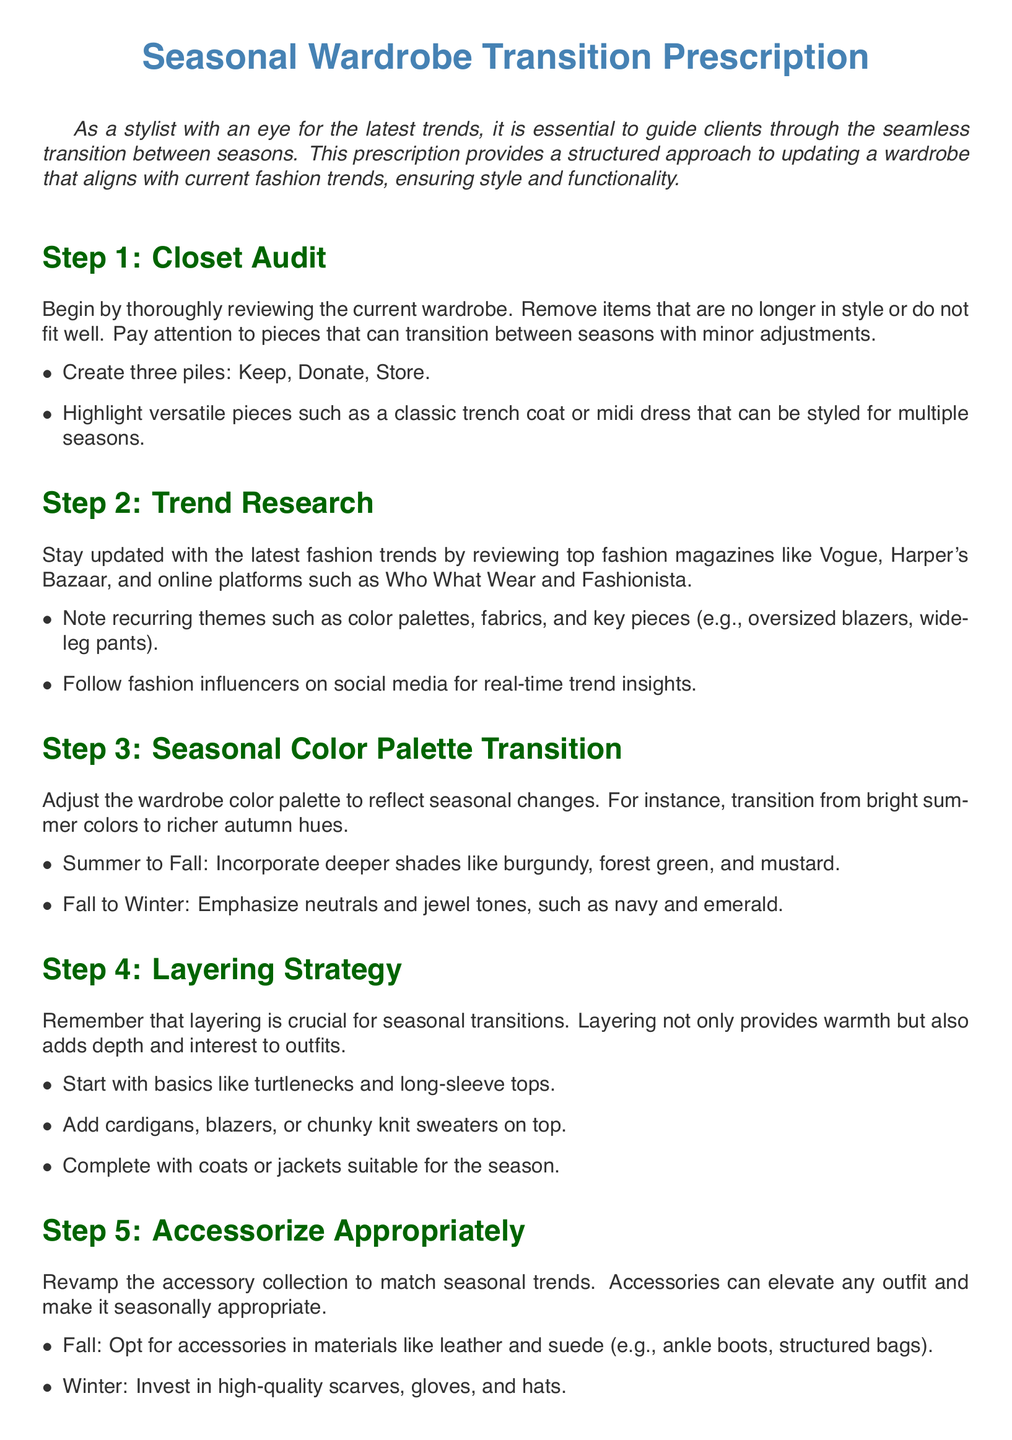What is the first step in the wardrobe transition? The first step is a Closet Audit, where clients review their current wardrobe.
Answer: Closet Audit What should be created during the closet audit? During the closet audit, three piles should be created: Keep, Donate, Store.
Answer: Keep, Donate, Store Which fashion magazines are recommended for trend research? The document recommends reviewing top fashion magazines such as Vogue and Harper's Bazaar for trend research.
Answer: Vogue, Harper's Bazaar What colors are suggested for the Summer to Fall transition? The suggested colors for the Summer to Fall transition include deeper shades like burgundy, forest green, and mustard.
Answer: Burgundy, forest green, mustard What is emphasized in Step 4 regarding outfit styling? Step 4 emphasizes that layering is crucial for seasonal transitions, adding warmth and depth to outfits.
Answer: Layering Which accessory materials are recommended for Fall? For Fall, accessories made of materials like leather and suede are recommended, such as ankle boots and structured bags.
Answer: Leather, suede What type of fashion choices does Step 6 encourage? Step 6 encourages sustainable and ethical choices in fashion, emphasizing timeless pieces and support for ethical brands.
Answer: Sustainable and ethical choices What should the updated wardrobe reflect according to Step 7? According to Step 7, the updated wardrobe should reflect the client's personal style and individuality.
Answer: Client's personal style What is the overall goal of following this prescription? The overall goal is to ensure clients have a curated, trend-forward closet that adapts to seasonal changes.
Answer: Trend-forward closet 